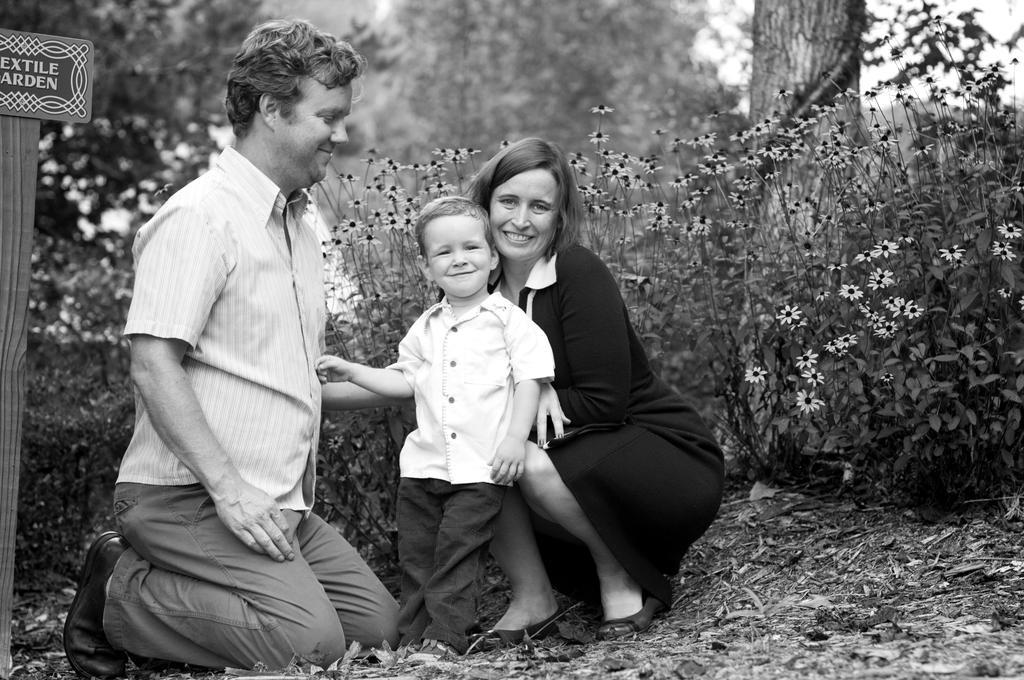How would you summarize this image in a sentence or two? In this image I can see three persons and I can see plants and flowers and trunk of tree and I can see a board attached to the pole on the left side. 